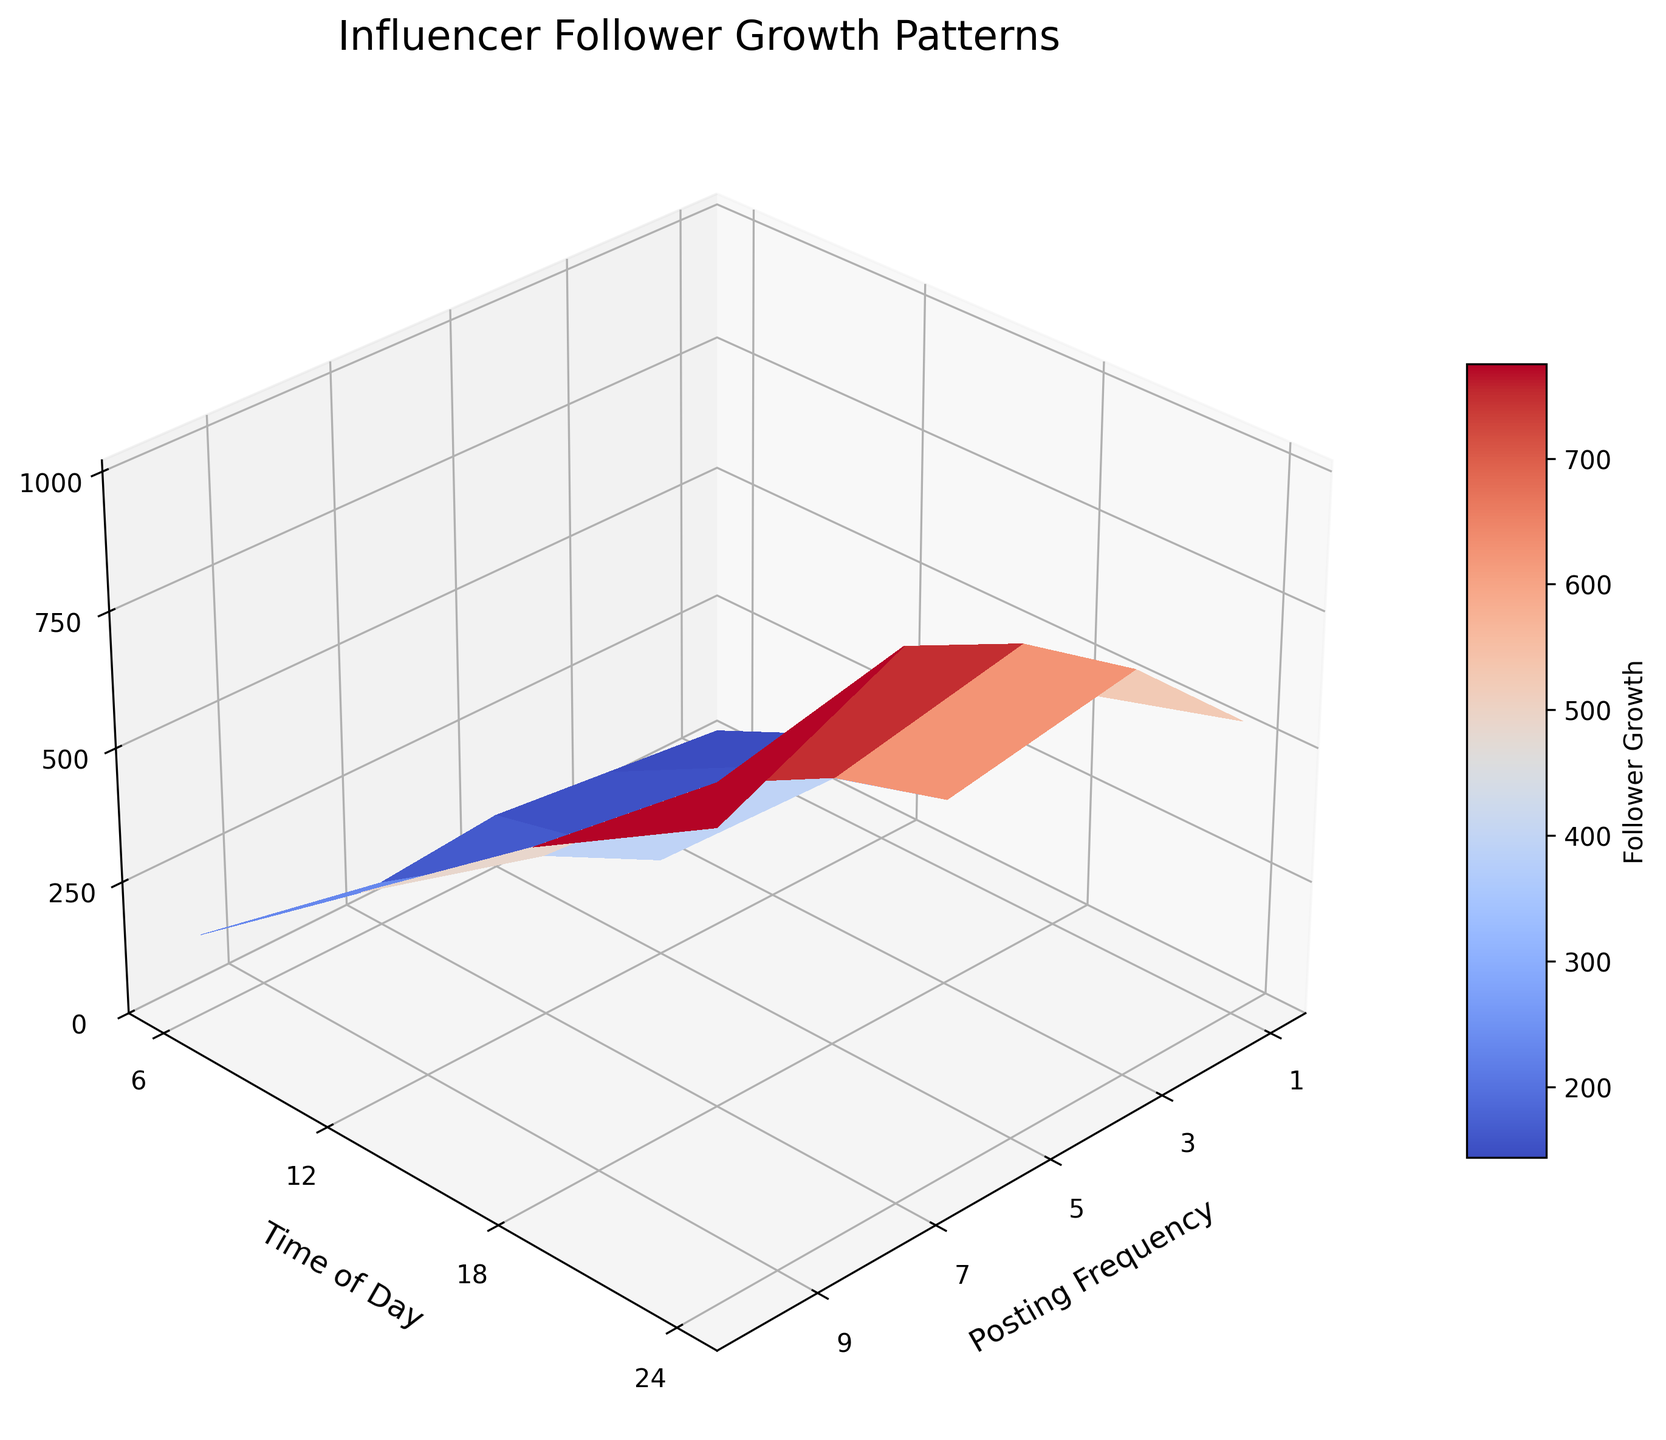What is the title of the plot? The title of the plot is located at the top center of the figure. By looking at this area, we can read the title of the plot.
Answer: Influencer Follower Growth Patterns What color scheme is used for the surface plot? The surface plot uses a color scheme that transitions through colors. By observing the color gradient on the plot, we can determine the name of the color scheme used.
Answer: Coolwarm What are the labels of the x-axis, y-axis, and z-axis? The axis labels are found along their respective axes. By reading each axis, we can identify the labels for the x-axis, y-axis, and z-axis.
Answer: Posting Frequency, Time of Day, Follower Growth What is the highest Follower Growth value and at what Posting Frequency and Time of Day is it achieved? To find the highest point on the plot, we look for the peak of the surface and identify the corresponding x, y, and z values. The highest Follower Growth is represented by the peak's z value.
Answer: 1000; at Posting Frequency 10 and Time of Day 18 How does Follower Growth change as Posting Frequency increases from 1 to 10 at Time of Day 6? By observing the curve along the z-axis for Time of Day 6 as Posting Frequency changes from 1 to 10, we analyze the trend in Follower Growth values.
Answer: It increases How does Posting Frequency of 5 affect Follower Growth at different times of the day? To determine the Follower Growth at Posting Frequency of 5, we look at the points on the plot where Posting Frequency is 5 and varying the Time of Day values. Comparing these points reveals the change.
Answer: 300 at 6, 400 at 12, 450 at 18, 350 at 24 Which Time of Day has the least impact on Follower Growth for a Posting Frequency of 7? Analyzing the Follower Growth values for Posting Frequency 7 at different times of the day helps identify the time with the minimum Follower Growth.
Answer: 6 What general trend can you observe between the Posting Frequency and Follower Growth? By looking at the surface plot as a whole, we can discern the overall trend as Posting Frequency increases and the corresponding change in Follower Growth.
Answer: Follower Growth generally increases with higher Posting Frequency How much does the Follower Growth increase when the Posting Frequency goes from 1 to 3 at Time of Day 18? Identify the Follower Growth values at Posting Frequency 1 and 3 for Time of Day 18, then calculate the difference between these values to determine the increase.
Answer: 150 What Posting Frequency results in the highest average Follower Growth across all times of day? To find the Posting Frequency with the highest average Follower Growth, calculate the mean Follower Growth for each Posting Frequency across all times of day and compare these averages.
Answer: 10 